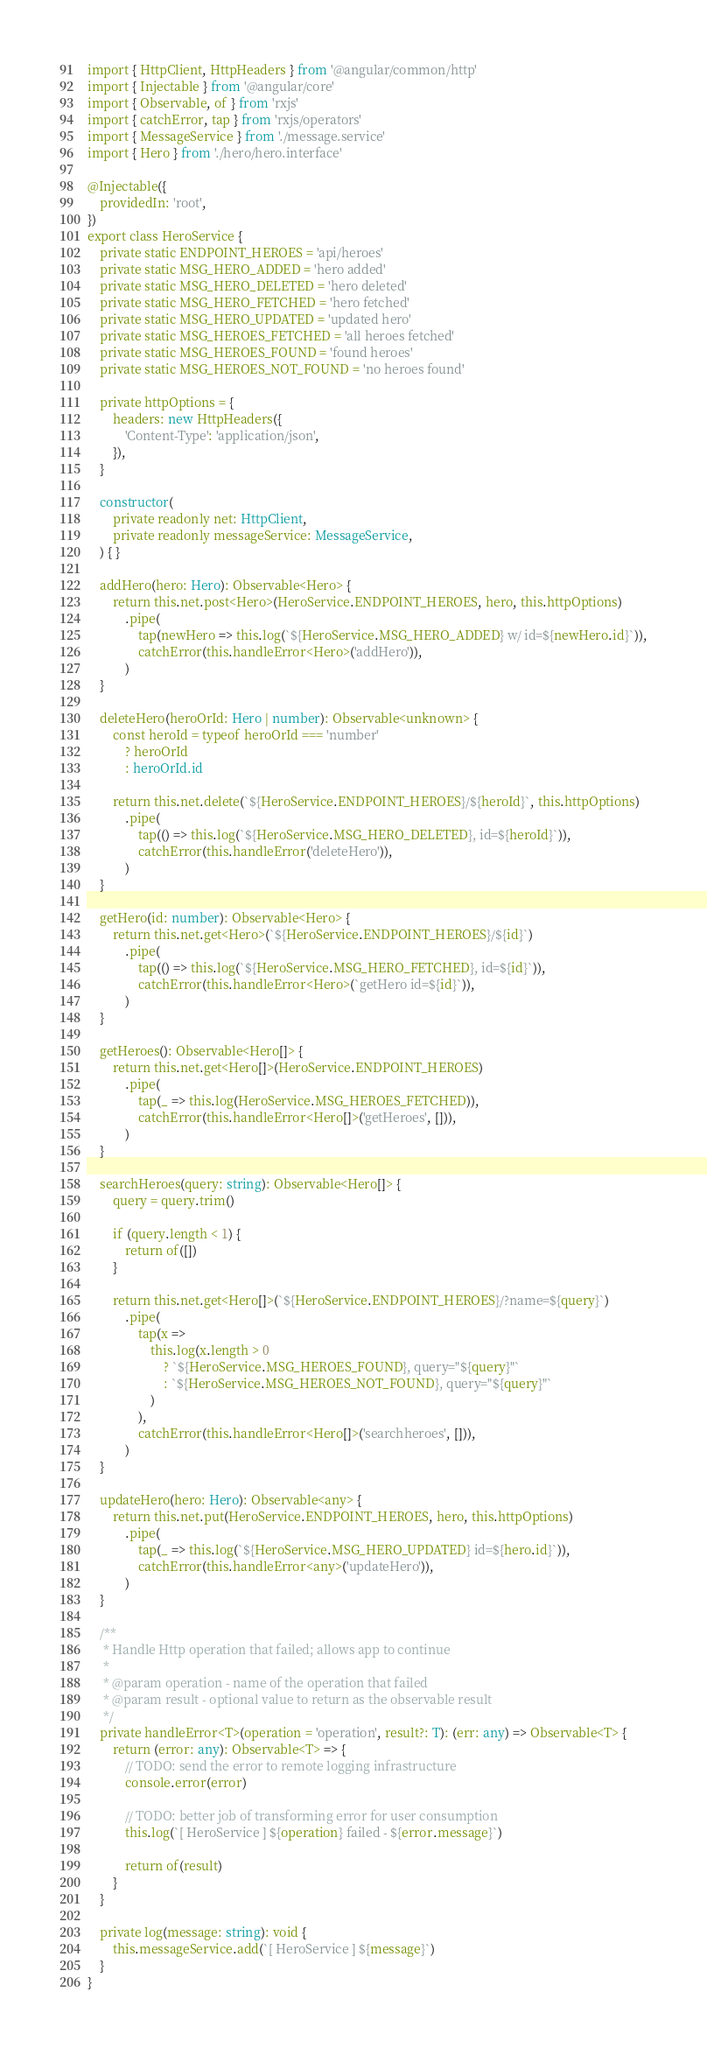<code> <loc_0><loc_0><loc_500><loc_500><_TypeScript_>import { HttpClient, HttpHeaders } from '@angular/common/http'
import { Injectable } from '@angular/core'
import { Observable, of } from 'rxjs'
import { catchError, tap } from 'rxjs/operators'
import { MessageService } from './message.service'
import { Hero } from './hero/hero.interface'

@Injectable({
	providedIn: 'root',
})
export class HeroService {
	private static ENDPOINT_HEROES = 'api/heroes'
	private static MSG_HERO_ADDED = 'hero added'
	private static MSG_HERO_DELETED = 'hero deleted'
	private static MSG_HERO_FETCHED = 'hero fetched'
	private static MSG_HERO_UPDATED = 'updated hero'
	private static MSG_HEROES_FETCHED = 'all heroes fetched'
	private static MSG_HEROES_FOUND = 'found heroes'
	private static MSG_HEROES_NOT_FOUND = 'no heroes found'

	private httpOptions = {
		headers: new HttpHeaders({
			'Content-Type': 'application/json',
		}),
	}

	constructor(
		private readonly net: HttpClient,
		private readonly messageService: MessageService,
	) { }

	addHero(hero: Hero): Observable<Hero> {
		return this.net.post<Hero>(HeroService.ENDPOINT_HEROES, hero, this.httpOptions)
			.pipe(
				tap(newHero => this.log(`${HeroService.MSG_HERO_ADDED} w/ id=${newHero.id}`)),
				catchError(this.handleError<Hero>('addHero')),
			)
	}

	deleteHero(heroOrId: Hero | number): Observable<unknown> {
		const heroId = typeof heroOrId === 'number'
			? heroOrId
			: heroOrId.id

		return this.net.delete(`${HeroService.ENDPOINT_HEROES}/${heroId}`, this.httpOptions)
			.pipe(
				tap(() => this.log(`${HeroService.MSG_HERO_DELETED}, id=${heroId}`)),
				catchError(this.handleError('deleteHero')),
			)
	}

	getHero(id: number): Observable<Hero> {
		return this.net.get<Hero>(`${HeroService.ENDPOINT_HEROES}/${id}`)
			.pipe(
				tap(() => this.log(`${HeroService.MSG_HERO_FETCHED}, id=${id}`)),
				catchError(this.handleError<Hero>(`getHero id=${id}`)),
			)
	}

	getHeroes(): Observable<Hero[]> {
		return this.net.get<Hero[]>(HeroService.ENDPOINT_HEROES)
			.pipe(
				tap(_ => this.log(HeroService.MSG_HEROES_FETCHED)),
				catchError(this.handleError<Hero[]>('getHeroes', [])),
			)
	}

	searchHeroes(query: string): Observable<Hero[]> {
		query = query.trim()

		if (query.length < 1) {
			return of([])
		}

		return this.net.get<Hero[]>(`${HeroService.ENDPOINT_HEROES}/?name=${query}`)
			.pipe(
				tap(x =>
					this.log(x.length > 0
						? `${HeroService.MSG_HEROES_FOUND}, query="${query}"`
						: `${HeroService.MSG_HEROES_NOT_FOUND}, query="${query}"`
					)
				),
				catchError(this.handleError<Hero[]>('searchheroes', [])),
			)
	}

	updateHero(hero: Hero): Observable<any> {
		return this.net.put(HeroService.ENDPOINT_HEROES, hero, this.httpOptions)
			.pipe(
				tap(_ => this.log(`${HeroService.MSG_HERO_UPDATED} id=${hero.id}`)),
				catchError(this.handleError<any>('updateHero')),
			)
	}

	/**
	 * Handle Http operation that failed; allows app to continue
	 *
	 * @param operation - name of the operation that failed
	 * @param result - optional value to return as the observable result
	 */
	private handleError<T>(operation = 'operation', result?: T): (err: any) => Observable<T> {
		return (error: any): Observable<T> => {
			// TODO: send the error to remote logging infrastructure
			console.error(error)

			// TODO: better job of transforming error for user consumption
			this.log(`[ HeroService ] ${operation} failed - ${error.message}`)

			return of(result)
		}
	}

	private log(message: string): void {
		this.messageService.add(`[ HeroService ] ${message}`)
	}
}
</code> 